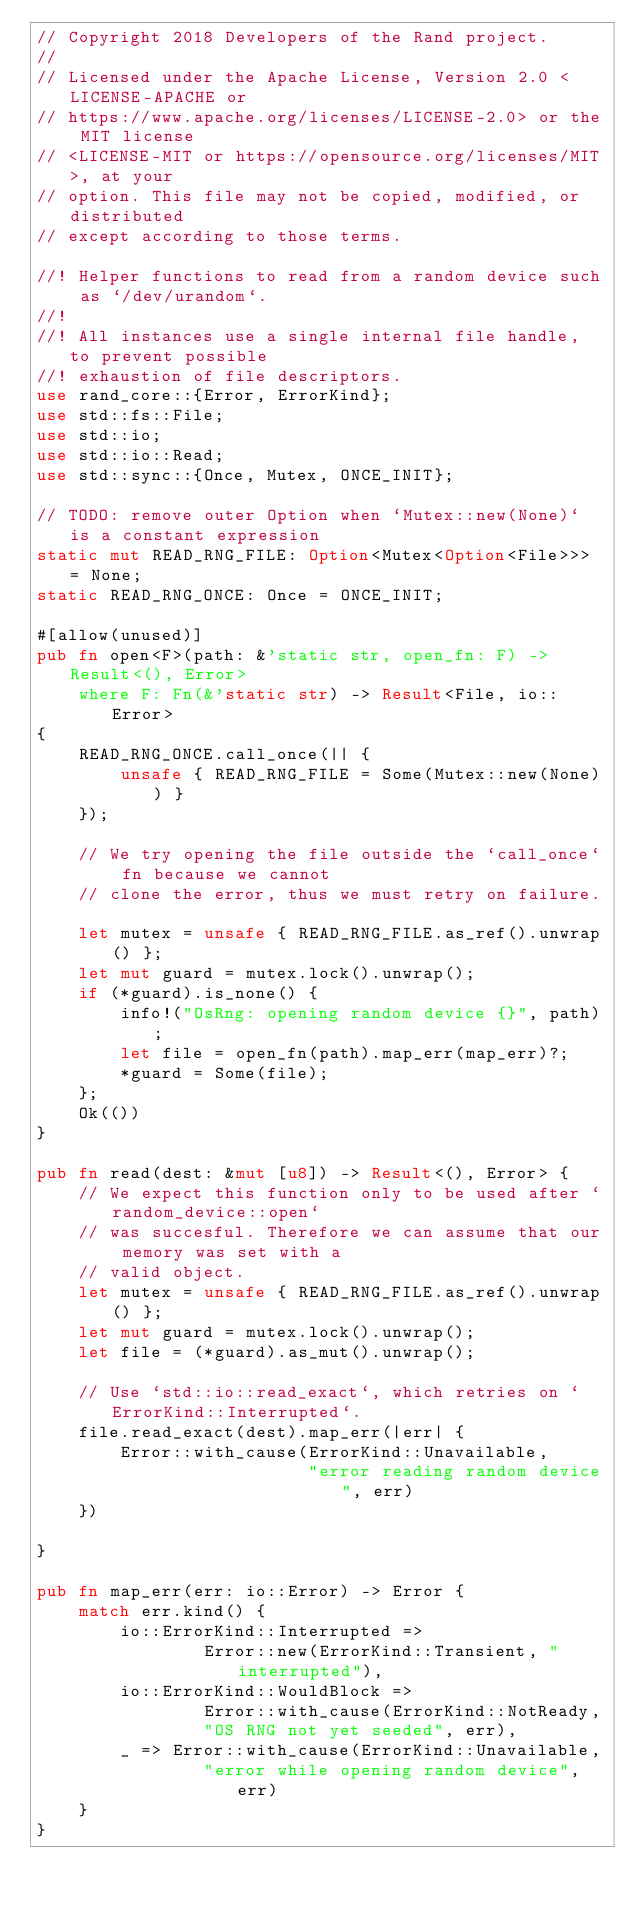Convert code to text. <code><loc_0><loc_0><loc_500><loc_500><_Rust_>// Copyright 2018 Developers of the Rand project.
//
// Licensed under the Apache License, Version 2.0 <LICENSE-APACHE or
// https://www.apache.org/licenses/LICENSE-2.0> or the MIT license
// <LICENSE-MIT or https://opensource.org/licenses/MIT>, at your
// option. This file may not be copied, modified, or distributed
// except according to those terms.

//! Helper functions to read from a random device such as `/dev/urandom`.
//!
//! All instances use a single internal file handle, to prevent possible
//! exhaustion of file descriptors.
use rand_core::{Error, ErrorKind};
use std::fs::File;
use std::io;
use std::io::Read;
use std::sync::{Once, Mutex, ONCE_INIT};

// TODO: remove outer Option when `Mutex::new(None)` is a constant expression
static mut READ_RNG_FILE: Option<Mutex<Option<File>>> = None;
static READ_RNG_ONCE: Once = ONCE_INIT;

#[allow(unused)]
pub fn open<F>(path: &'static str, open_fn: F) -> Result<(), Error>
    where F: Fn(&'static str) -> Result<File, io::Error>
{
    READ_RNG_ONCE.call_once(|| {
        unsafe { READ_RNG_FILE = Some(Mutex::new(None)) }
    });

    // We try opening the file outside the `call_once` fn because we cannot
    // clone the error, thus we must retry on failure.

    let mutex = unsafe { READ_RNG_FILE.as_ref().unwrap() };
    let mut guard = mutex.lock().unwrap();
    if (*guard).is_none() {
        info!("OsRng: opening random device {}", path);
        let file = open_fn(path).map_err(map_err)?;
        *guard = Some(file);
    };
    Ok(())
}

pub fn read(dest: &mut [u8]) -> Result<(), Error> {
    // We expect this function only to be used after `random_device::open`
    // was succesful. Therefore we can assume that our memory was set with a
    // valid object.
    let mutex = unsafe { READ_RNG_FILE.as_ref().unwrap() };
    let mut guard = mutex.lock().unwrap();
    let file = (*guard).as_mut().unwrap();

    // Use `std::io::read_exact`, which retries on `ErrorKind::Interrupted`.
    file.read_exact(dest).map_err(|err| {
        Error::with_cause(ErrorKind::Unavailable,
                          "error reading random device", err)
    })

}

pub fn map_err(err: io::Error) -> Error {
    match err.kind() {
        io::ErrorKind::Interrupted =>
                Error::new(ErrorKind::Transient, "interrupted"),
        io::ErrorKind::WouldBlock =>
                Error::with_cause(ErrorKind::NotReady,
                "OS RNG not yet seeded", err),
        _ => Error::with_cause(ErrorKind::Unavailable,
                "error while opening random device", err)
    }
}
</code> 